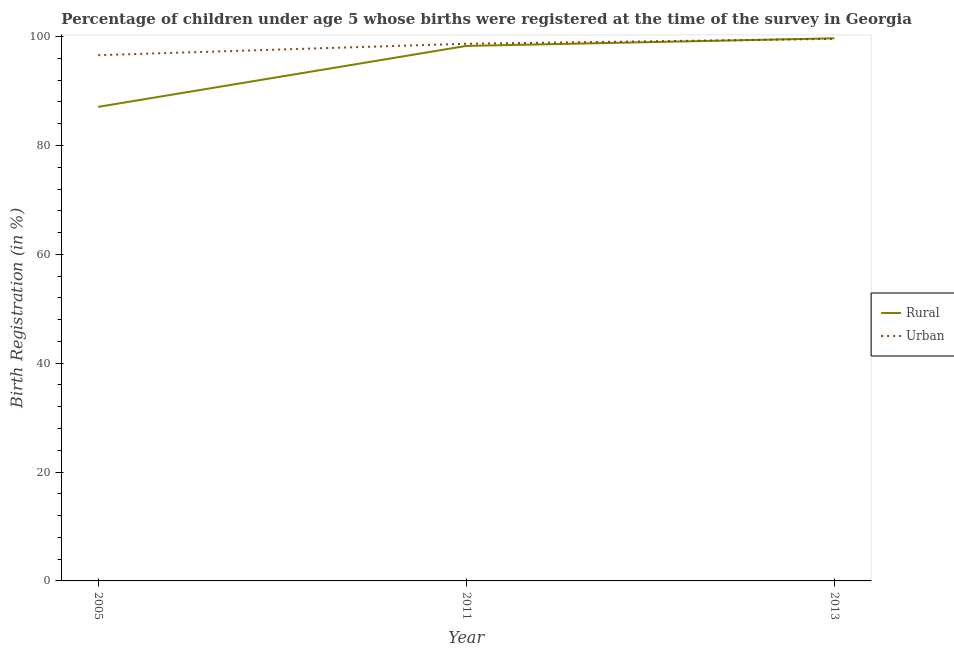What is the urban birth registration in 2005?
Your answer should be very brief. 96.6. Across all years, what is the maximum rural birth registration?
Your response must be concise. 99.7. Across all years, what is the minimum urban birth registration?
Make the answer very short. 96.6. In which year was the rural birth registration minimum?
Give a very brief answer. 2005. What is the total rural birth registration in the graph?
Ensure brevity in your answer.  285.1. What is the difference between the urban birth registration in 2005 and that in 2011?
Your response must be concise. -2.1. What is the difference between the rural birth registration in 2011 and the urban birth registration in 2005?
Ensure brevity in your answer.  1.7. What is the average rural birth registration per year?
Your response must be concise. 95.03. In the year 2013, what is the difference between the rural birth registration and urban birth registration?
Your answer should be very brief. 0.1. What is the ratio of the rural birth registration in 2005 to that in 2013?
Make the answer very short. 0.87. Is the rural birth registration in 2005 less than that in 2011?
Provide a succinct answer. Yes. What is the difference between the highest and the second highest rural birth registration?
Your response must be concise. 1.4. What is the difference between the highest and the lowest rural birth registration?
Provide a succinct answer. 12.6. In how many years, is the urban birth registration greater than the average urban birth registration taken over all years?
Your answer should be very brief. 2. Is the urban birth registration strictly greater than the rural birth registration over the years?
Provide a short and direct response. No. How many years are there in the graph?
Keep it short and to the point. 3. What is the difference between two consecutive major ticks on the Y-axis?
Keep it short and to the point. 20. What is the title of the graph?
Offer a terse response. Percentage of children under age 5 whose births were registered at the time of the survey in Georgia. What is the label or title of the Y-axis?
Offer a terse response. Birth Registration (in %). What is the Birth Registration (in %) in Rural in 2005?
Provide a short and direct response. 87.1. What is the Birth Registration (in %) of Urban in 2005?
Offer a very short reply. 96.6. What is the Birth Registration (in %) of Rural in 2011?
Provide a succinct answer. 98.3. What is the Birth Registration (in %) in Urban in 2011?
Your answer should be compact. 98.7. What is the Birth Registration (in %) of Rural in 2013?
Make the answer very short. 99.7. What is the Birth Registration (in %) in Urban in 2013?
Ensure brevity in your answer.  99.6. Across all years, what is the maximum Birth Registration (in %) of Rural?
Make the answer very short. 99.7. Across all years, what is the maximum Birth Registration (in %) of Urban?
Keep it short and to the point. 99.6. Across all years, what is the minimum Birth Registration (in %) in Rural?
Give a very brief answer. 87.1. Across all years, what is the minimum Birth Registration (in %) in Urban?
Provide a succinct answer. 96.6. What is the total Birth Registration (in %) in Rural in the graph?
Offer a terse response. 285.1. What is the total Birth Registration (in %) of Urban in the graph?
Offer a terse response. 294.9. What is the difference between the Birth Registration (in %) of Rural in 2005 and that in 2011?
Make the answer very short. -11.2. What is the difference between the Birth Registration (in %) of Urban in 2005 and that in 2011?
Ensure brevity in your answer.  -2.1. What is the difference between the Birth Registration (in %) in Urban in 2005 and that in 2013?
Provide a succinct answer. -3. What is the difference between the Birth Registration (in %) of Rural in 2011 and that in 2013?
Provide a short and direct response. -1.4. What is the difference between the Birth Registration (in %) of Urban in 2011 and that in 2013?
Your response must be concise. -0.9. What is the difference between the Birth Registration (in %) in Rural in 2005 and the Birth Registration (in %) in Urban in 2013?
Your response must be concise. -12.5. What is the average Birth Registration (in %) of Rural per year?
Offer a very short reply. 95.03. What is the average Birth Registration (in %) in Urban per year?
Offer a terse response. 98.3. In the year 2005, what is the difference between the Birth Registration (in %) in Rural and Birth Registration (in %) in Urban?
Offer a very short reply. -9.5. What is the ratio of the Birth Registration (in %) in Rural in 2005 to that in 2011?
Your response must be concise. 0.89. What is the ratio of the Birth Registration (in %) of Urban in 2005 to that in 2011?
Offer a very short reply. 0.98. What is the ratio of the Birth Registration (in %) of Rural in 2005 to that in 2013?
Provide a short and direct response. 0.87. What is the ratio of the Birth Registration (in %) of Urban in 2005 to that in 2013?
Ensure brevity in your answer.  0.97. What is the difference between the highest and the second highest Birth Registration (in %) of Urban?
Your response must be concise. 0.9. What is the difference between the highest and the lowest Birth Registration (in %) in Rural?
Ensure brevity in your answer.  12.6. 